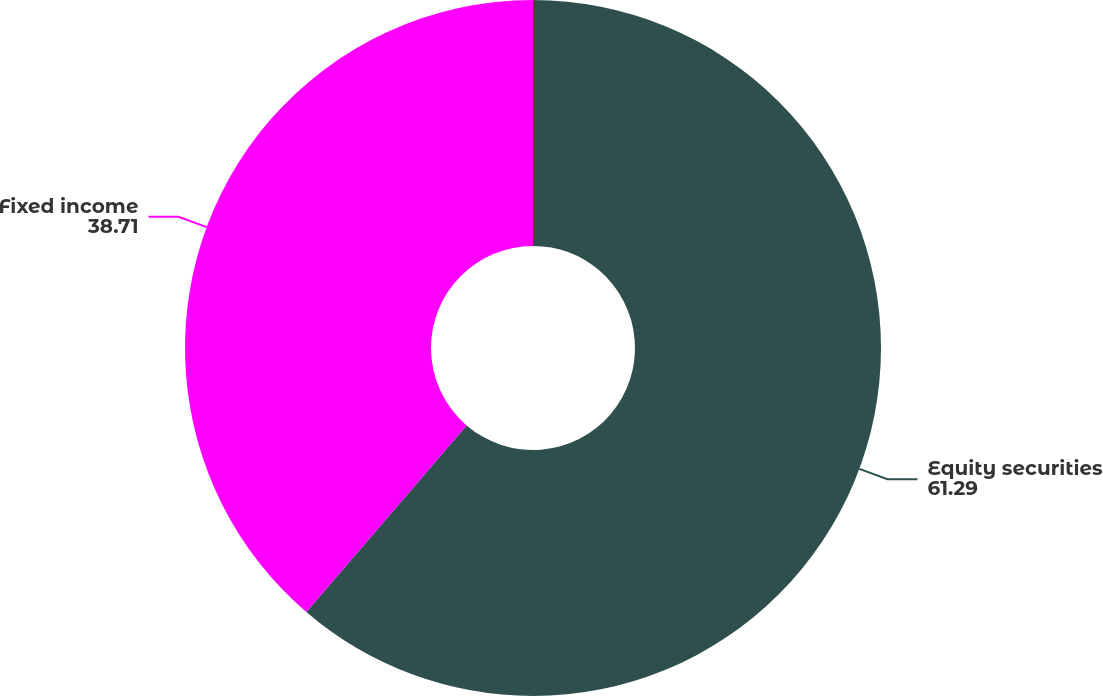Convert chart to OTSL. <chart><loc_0><loc_0><loc_500><loc_500><pie_chart><fcel>Equity securities<fcel>Fixed income<nl><fcel>61.29%<fcel>38.71%<nl></chart> 